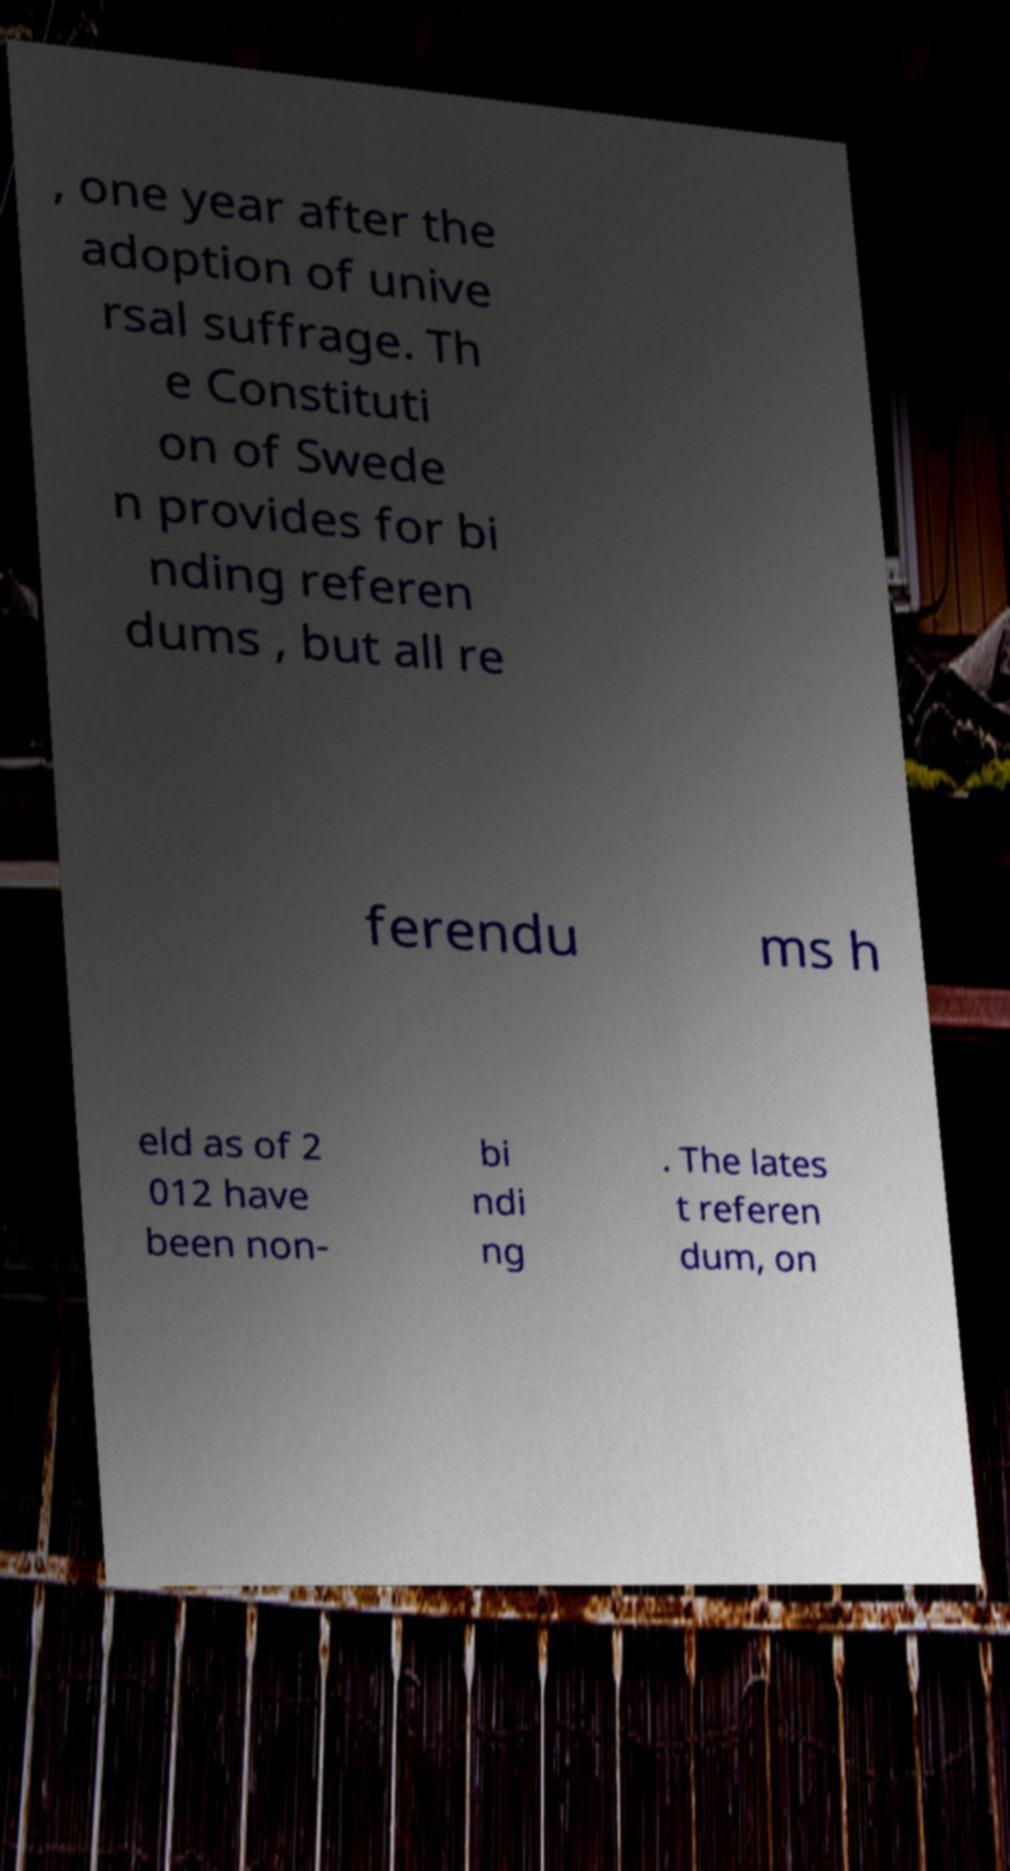Can you read and provide the text displayed in the image?This photo seems to have some interesting text. Can you extract and type it out for me? , one year after the adoption of unive rsal suffrage. Th e Constituti on of Swede n provides for bi nding referen dums , but all re ferendu ms h eld as of 2 012 have been non- bi ndi ng . The lates t referen dum, on 